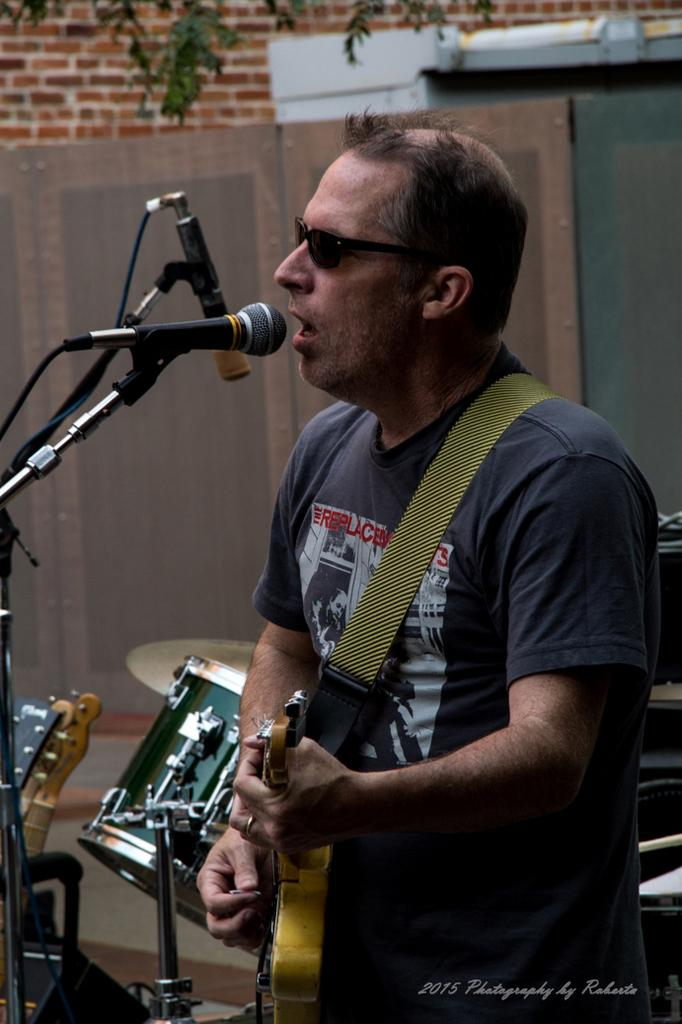What is the man in the image doing? The man is standing and playing the guitar, and he is also singing. What instrument can be seen in the image besides the guitar? There are drums visible in the image. What object is in front of the man? There is a microphone in front of the man. What type of wall is present in the image? There is a wall made of bricks in the image. How many oranges are on the wall in the image? There are no oranges present in the image; the wall is made of bricks. Can you tell me how the fly is interacting with the microphone in the image? There is no fly present in the image; the focus is on the man playing the guitar and singing. 